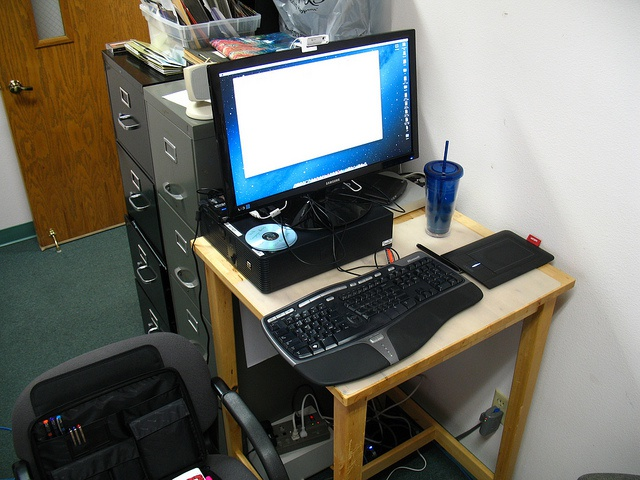Describe the objects in this image and their specific colors. I can see tv in maroon, white, black, lightblue, and navy tones, handbag in maroon, black, white, and gray tones, keyboard in maroon, black, gray, darkgray, and purple tones, and cup in maroon, navy, gray, darkblue, and blue tones in this image. 